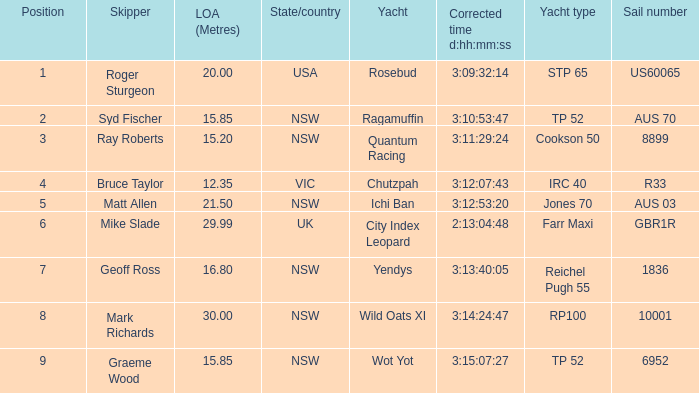What were all Yachts with a sail number of 6952? Wot Yot. Parse the table in full. {'header': ['Position', 'Skipper', 'LOA (Metres)', 'State/country', 'Yacht', 'Corrected time d:hh:mm:ss', 'Yacht type', 'Sail number'], 'rows': [['1', 'Roger Sturgeon', '20.00', 'USA', 'Rosebud', '3:09:32:14', 'STP 65', 'US60065'], ['2', 'Syd Fischer', '15.85', 'NSW', 'Ragamuffin', '3:10:53:47', 'TP 52', 'AUS 70'], ['3', 'Ray Roberts', '15.20', 'NSW', 'Quantum Racing', '3:11:29:24', 'Cookson 50', '8899'], ['4', 'Bruce Taylor', '12.35', 'VIC', 'Chutzpah', '3:12:07:43', 'IRC 40', 'R33'], ['5', 'Matt Allen', '21.50', 'NSW', 'Ichi Ban', '3:12:53:20', 'Jones 70', 'AUS 03'], ['6', 'Mike Slade', '29.99', 'UK', 'City Index Leopard', '2:13:04:48', 'Farr Maxi', 'GBR1R'], ['7', 'Geoff Ross', '16.80', 'NSW', 'Yendys', '3:13:40:05', 'Reichel Pugh 55', '1836'], ['8', 'Mark Richards', '30.00', 'NSW', 'Wild Oats XI', '3:14:24:47', 'RP100', '10001'], ['9', 'Graeme Wood', '15.85', 'NSW', 'Wot Yot', '3:15:07:27', 'TP 52', '6952']]} 